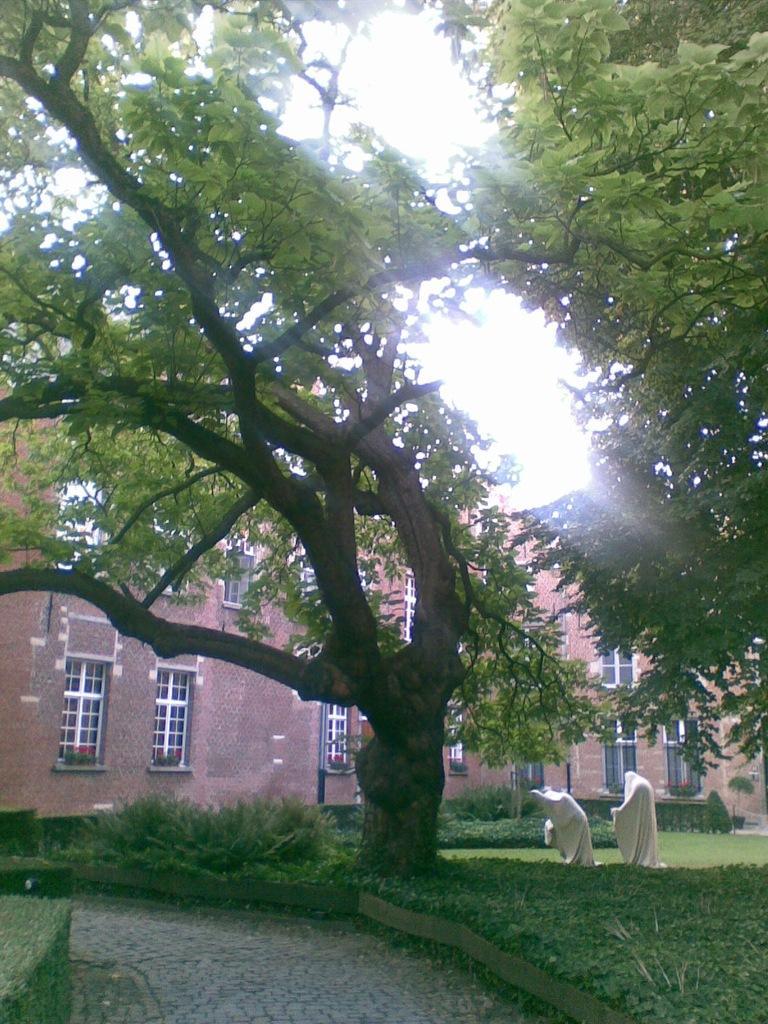Can you describe this image briefly? In this picture there is huge tree in the middle of the garden. Behind there is a brown color brick building with white color glass windows. 